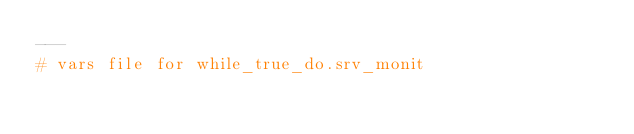Convert code to text. <code><loc_0><loc_0><loc_500><loc_500><_YAML_>---
# vars file for while_true_do.srv_monit
</code> 